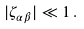<formula> <loc_0><loc_0><loc_500><loc_500>| \zeta _ { \alpha \beta } | \ll 1 \, .</formula> 